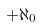<formula> <loc_0><loc_0><loc_500><loc_500>+ \aleph _ { 0 }</formula> 